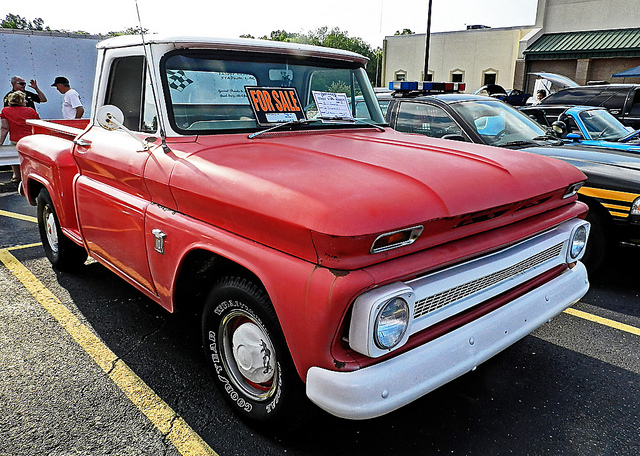Read all the text in this image. FOR SALE Good 